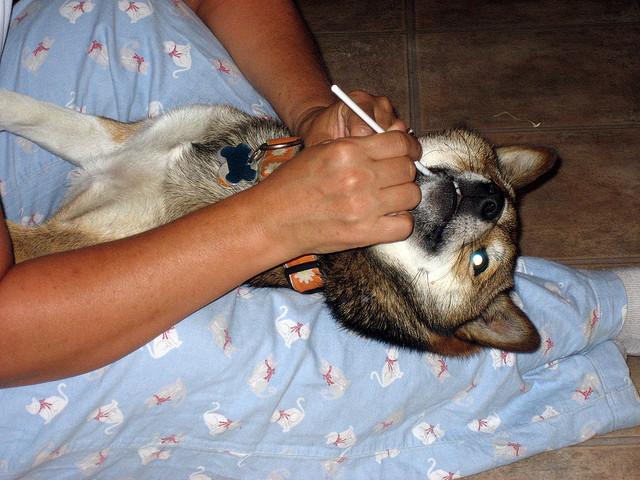Was flash used in taking this photo?
Be succinct. Yes. Is this a dog or a cat?
Give a very brief answer. Dog. Who took this picture?
Answer briefly. Man. 